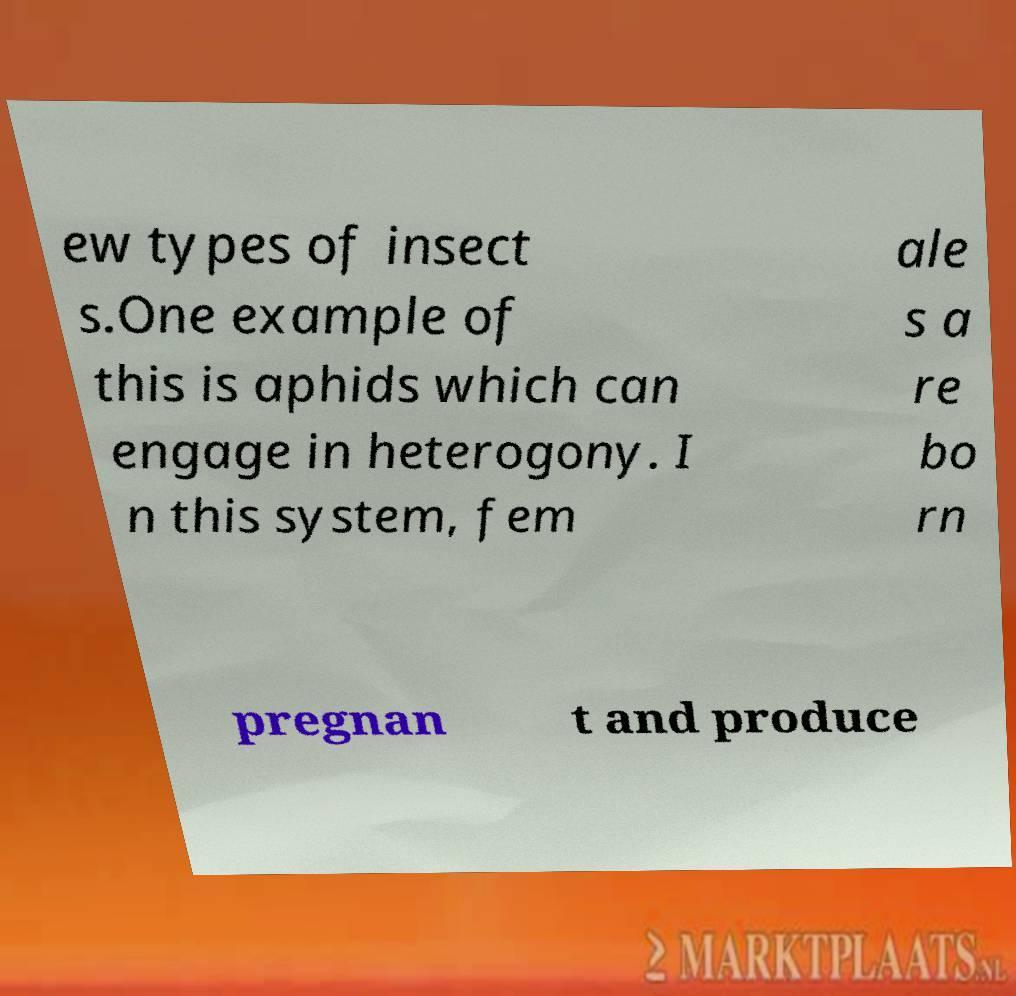I need the written content from this picture converted into text. Can you do that? ew types of insect s.One example of this is aphids which can engage in heterogony. I n this system, fem ale s a re bo rn pregnan t and produce 